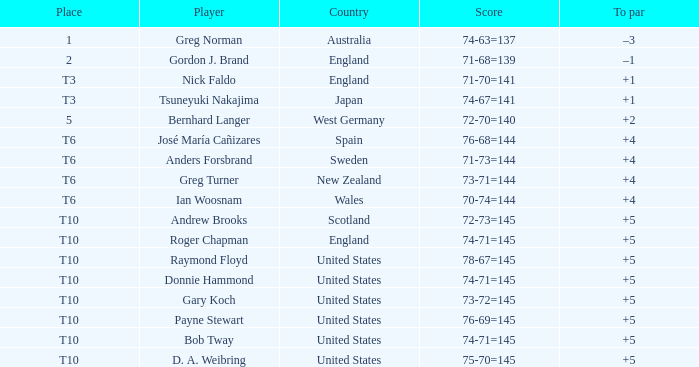What standing did united states hold when the competitor was raymond floyd? T10. 